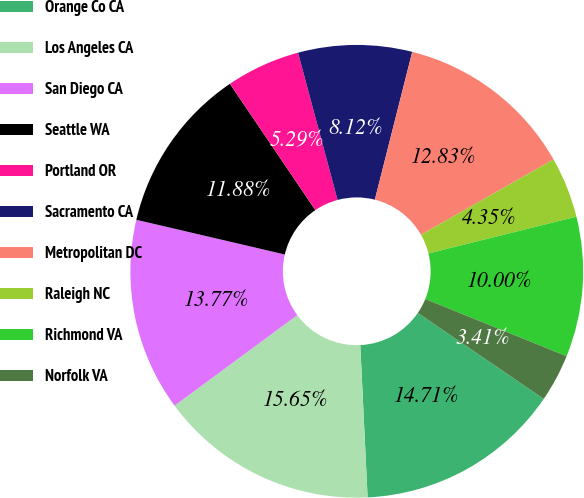Convert chart. <chart><loc_0><loc_0><loc_500><loc_500><pie_chart><fcel>Orange Co CA<fcel>Los Angeles CA<fcel>San Diego CA<fcel>Seattle WA<fcel>Portland OR<fcel>Sacramento CA<fcel>Metropolitan DC<fcel>Raleigh NC<fcel>Richmond VA<fcel>Norfolk VA<nl><fcel>14.71%<fcel>15.65%<fcel>13.77%<fcel>11.88%<fcel>5.29%<fcel>8.12%<fcel>12.83%<fcel>4.35%<fcel>10.0%<fcel>3.41%<nl></chart> 